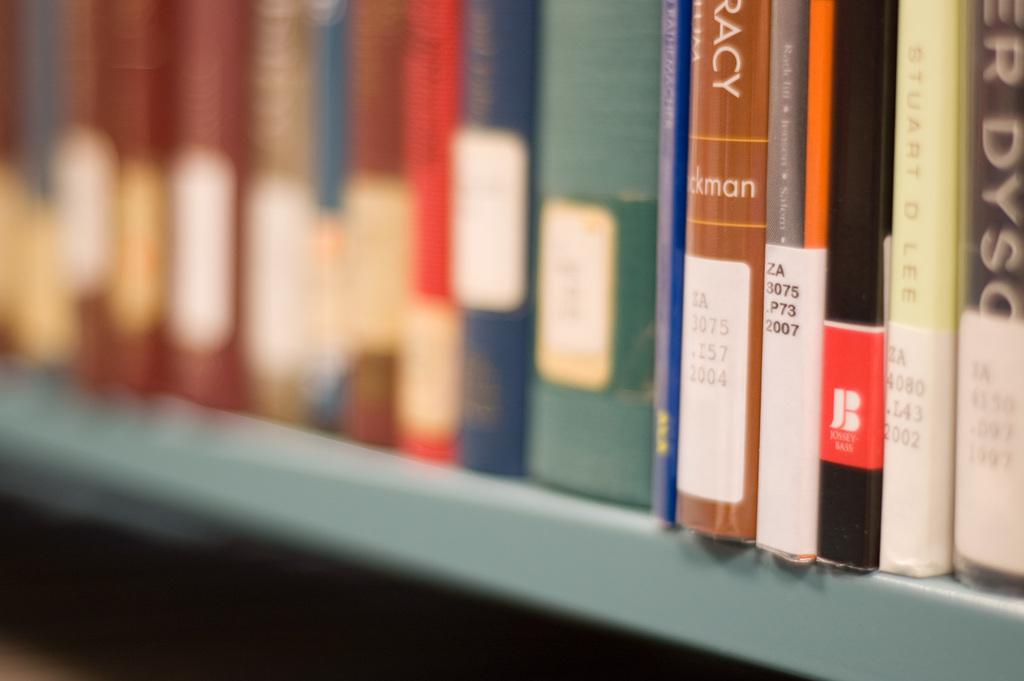What type of objects can be seen in the image? There are books in the image. Can you describe the books in the image? Unfortunately, the facts provided do not give any details about the books, such as their titles, colors, or arrangement. Are the books the only objects in the image? The facts provided do not mention any other objects in the image, so we cannot confirm or deny their presence. What type of farm animals can be seen in the image? There is no mention of farm animals or any other subjects besides books in the image, so we cannot answer this question. 